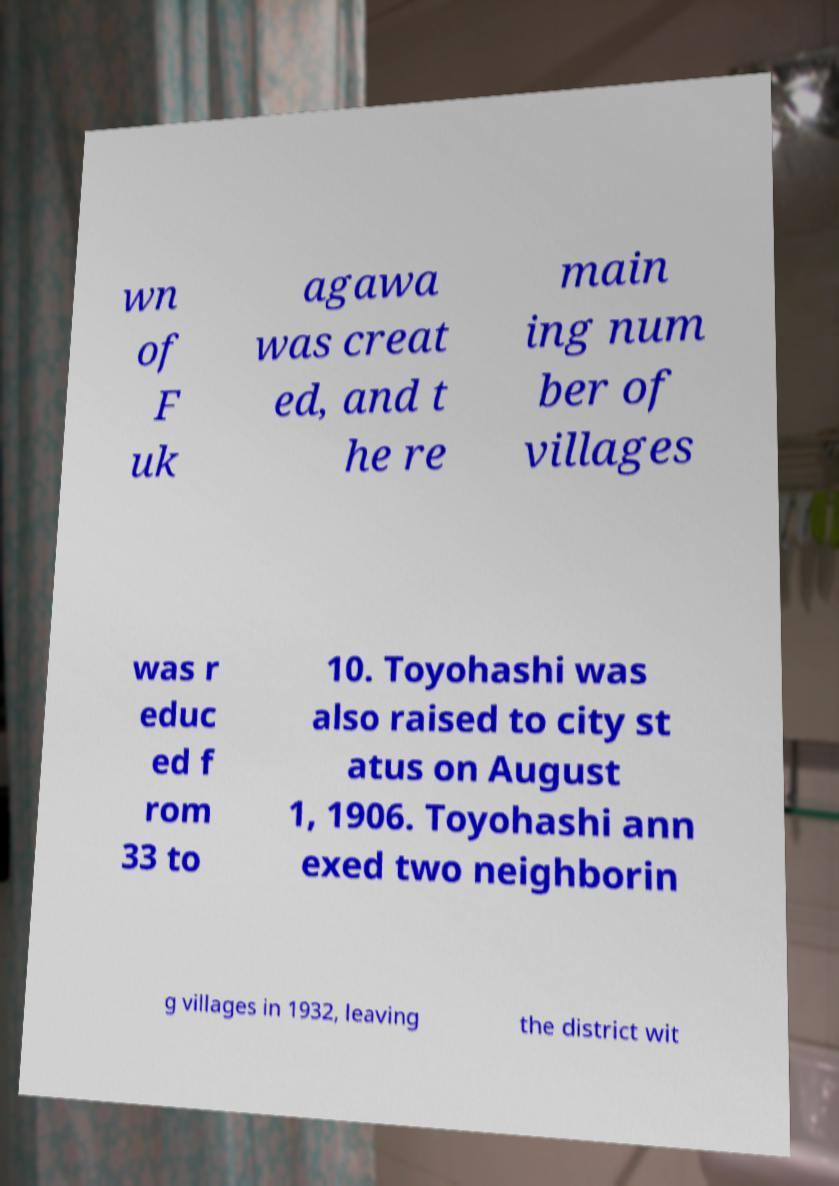There's text embedded in this image that I need extracted. Can you transcribe it verbatim? wn of F uk agawa was creat ed, and t he re main ing num ber of villages was r educ ed f rom 33 to 10. Toyohashi was also raised to city st atus on August 1, 1906. Toyohashi ann exed two neighborin g villages in 1932, leaving the district wit 